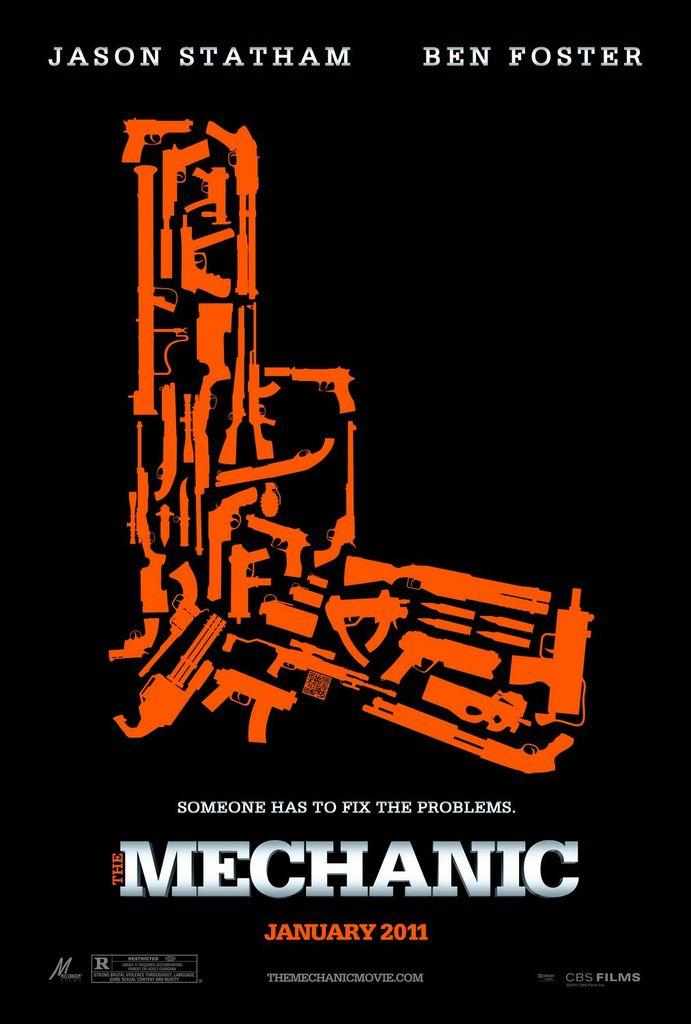<image>
Offer a succinct explanation of the picture presented. a movie called The Mechanic with Ben Foster in it 